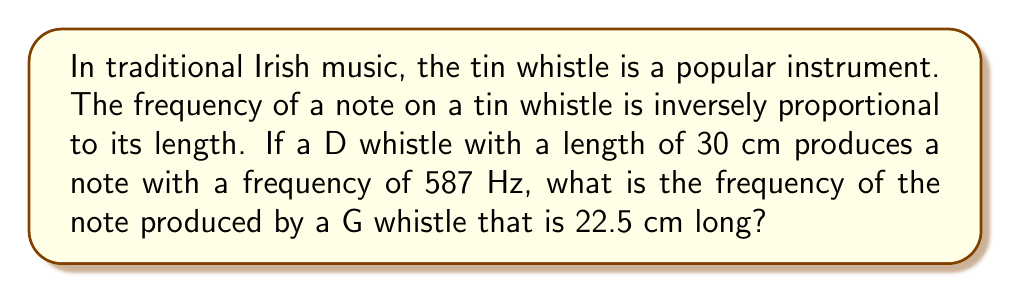Teach me how to tackle this problem. Let's approach this step-by-step using the inverse proportion relationship:

1) Let $f_1$ and $l_1$ be the frequency and length of the D whistle, and $f_2$ and $l_2$ be the frequency and length of the G whistle.

2) The inverse proportion relationship can be expressed as:

   $f_1 l_1 = f_2 l_2$

3) We know:
   $f_1 = 587$ Hz
   $l_1 = 30$ cm
   $l_2 = 22.5$ cm

4) Substituting these values:

   $587 \cdot 30 = f_2 \cdot 22.5$

5) Simplify the left side:

   $17610 = f_2 \cdot 22.5$

6) Solve for $f_2$:

   $f_2 = \frac{17610}{22.5} = 782.67$ Hz

Therefore, the G whistle produces a note with a frequency of approximately 782.67 Hz.
Answer: 782.67 Hz 